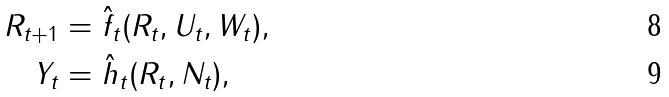Convert formula to latex. <formula><loc_0><loc_0><loc_500><loc_500>R _ { t + 1 } & = \hat { f } _ { t } ( R _ { t } , U _ { t } , W _ { t } ) , \\ Y _ { t } & = \hat { h } _ { t } ( R _ { t } , N _ { t } ) ,</formula> 